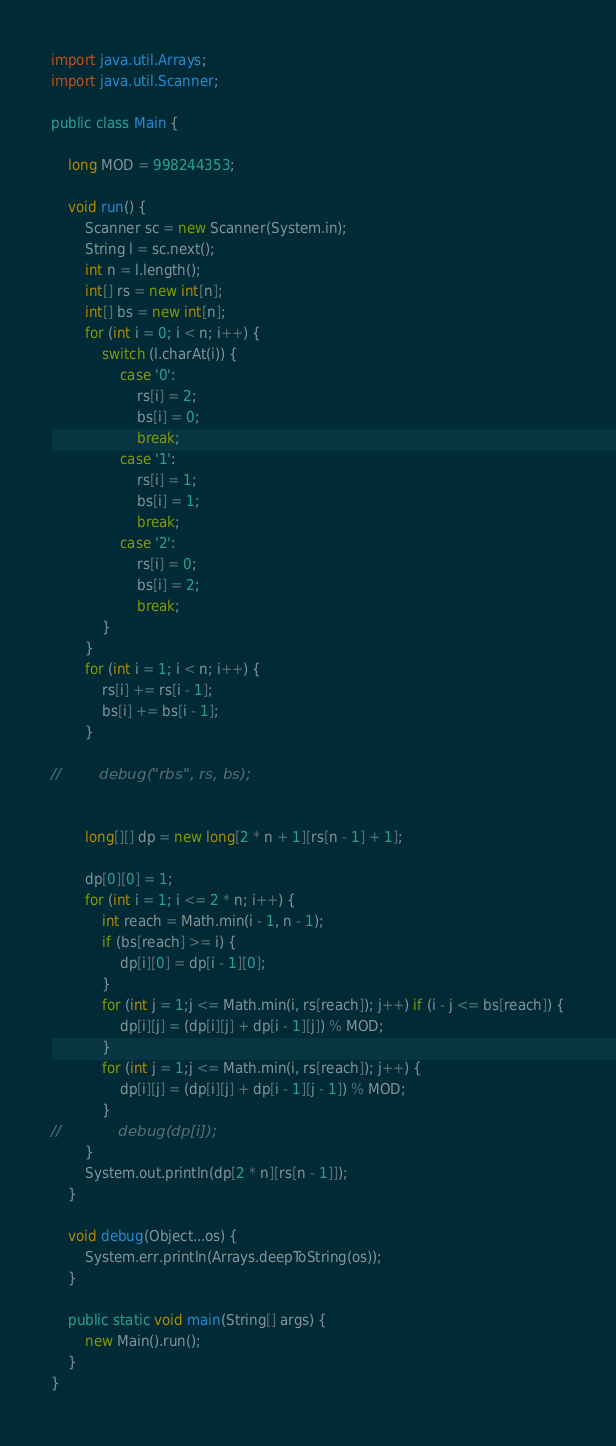<code> <loc_0><loc_0><loc_500><loc_500><_Java_>
import java.util.Arrays;
import java.util.Scanner;

public class Main {

    long MOD = 998244353;

    void run() {
        Scanner sc = new Scanner(System.in);
        String l = sc.next();
        int n = l.length();
        int[] rs = new int[n];
        int[] bs = new int[n];
        for (int i = 0; i < n; i++) {
            switch (l.charAt(i)) {
                case '0':
                    rs[i] = 2;
                    bs[i] = 0;
                    break;
                case '1':
                    rs[i] = 1;
                    bs[i] = 1;
                    break;
                case '2':
                    rs[i] = 0;
                    bs[i] = 2;
                    break;
            }
        }
        for (int i = 1; i < n; i++) {
            rs[i] += rs[i - 1];
            bs[i] += bs[i - 1];
        }

//        debug("rbs", rs, bs);


        long[][] dp = new long[2 * n + 1][rs[n - 1] + 1];

        dp[0][0] = 1;
        for (int i = 1; i <= 2 * n; i++) {
            int reach = Math.min(i - 1, n - 1);
            if (bs[reach] >= i) {
                dp[i][0] = dp[i - 1][0];
            }
            for (int j = 1;j <= Math.min(i, rs[reach]); j++) if (i - j <= bs[reach]) {
                dp[i][j] = (dp[i][j] + dp[i - 1][j]) % MOD;
            }
            for (int j = 1;j <= Math.min(i, rs[reach]); j++) {
                dp[i][j] = (dp[i][j] + dp[i - 1][j - 1]) % MOD;
            }
//            debug(dp[i]);
        }
        System.out.println(dp[2 * n][rs[n - 1]]);
    }

    void debug(Object...os) {
        System.err.println(Arrays.deepToString(os));
    }

    public static void main(String[] args) {
        new Main().run();
    }
}
</code> 